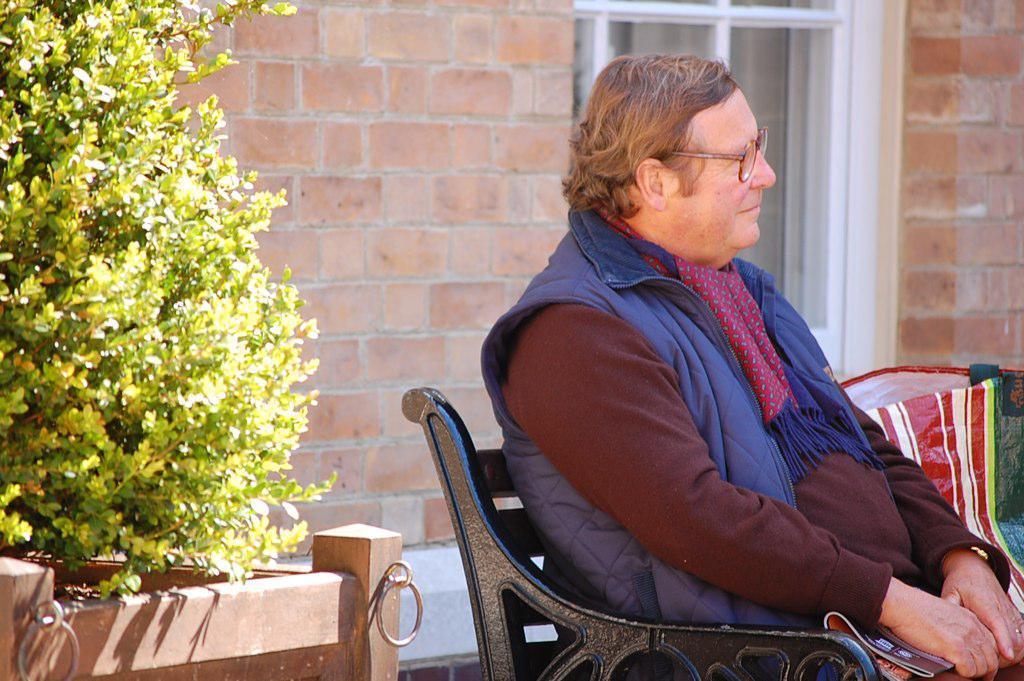Please provide a concise description of this image. To the left side of the image there is a plant inside the fencing. And to the right side of the image there is a black bench. On the bench there is a man with a blue jacket, maroon t-shirt and red stole around his neck is sitting on the bench. Beside him there is bag. And in the background there is a brick wall and white window. 